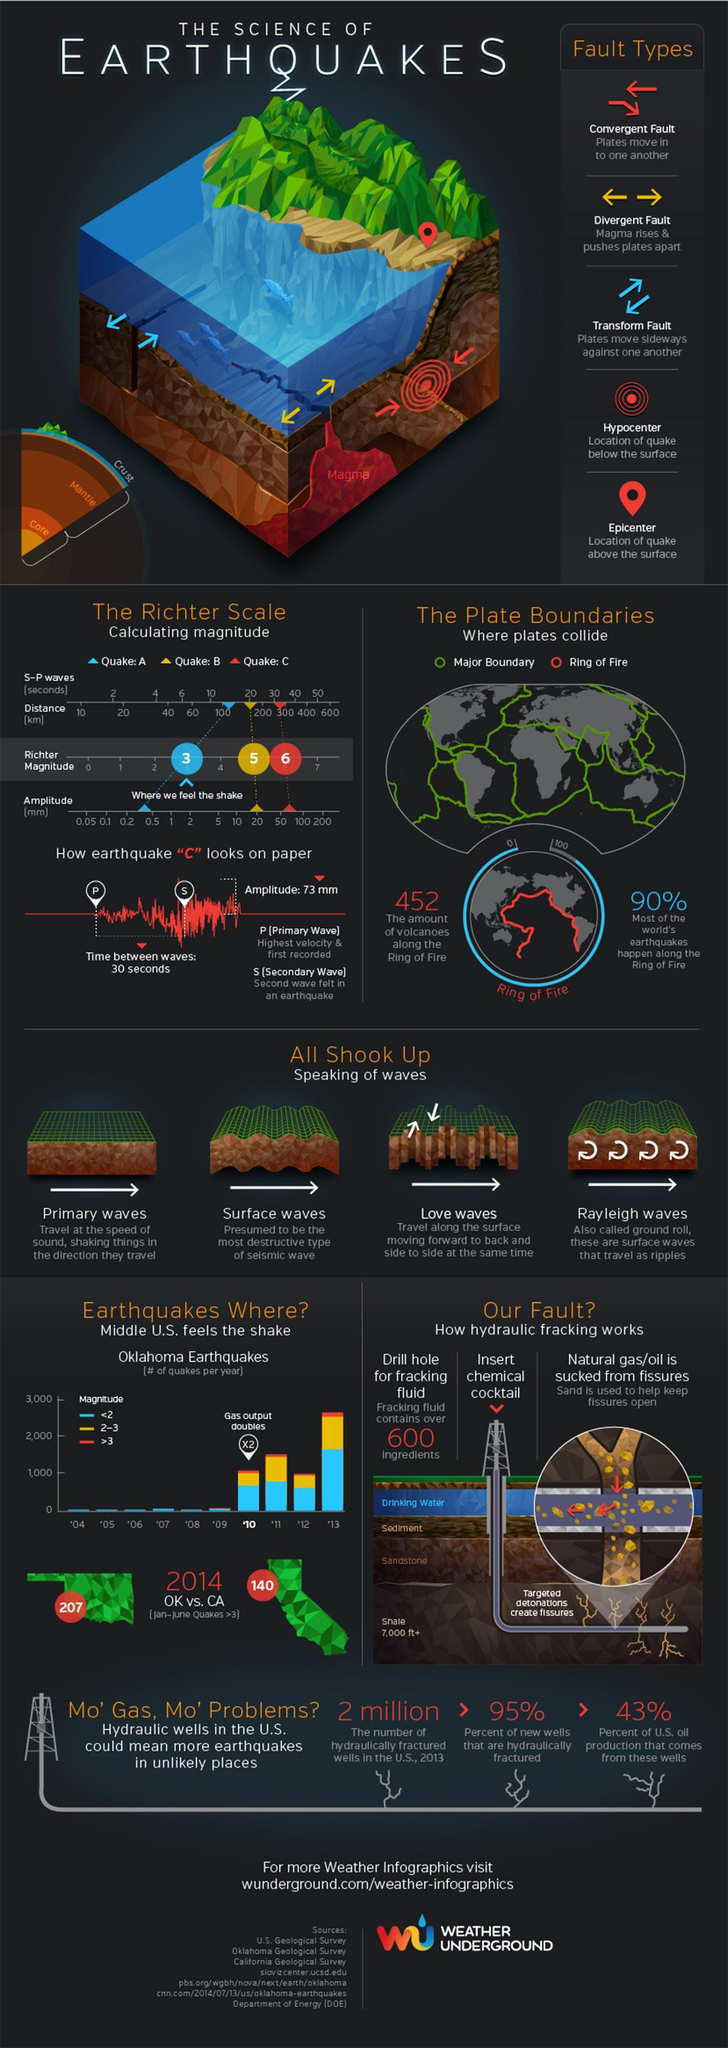Indicate a few pertinent items in this graphic. Rayleigh waves are the type of elastic waves that are generated by the movement of the ground, and are commonly referred to as "ground roll. There are five types of faults mentioned in this infographic. There are four types of waves mentioned in this infographic. Only 10% of earthquakes occur outside of the Ring of Fire. 